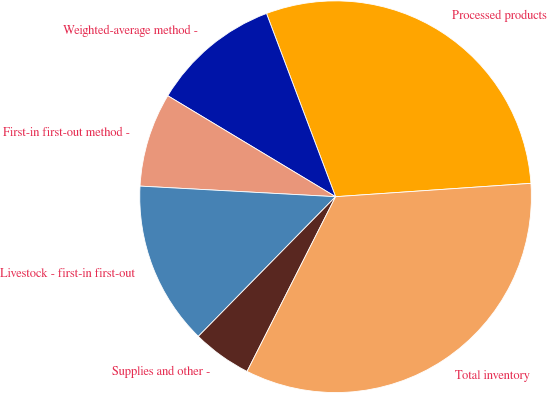Convert chart to OTSL. <chart><loc_0><loc_0><loc_500><loc_500><pie_chart><fcel>Processed products<fcel>Weighted-average method -<fcel>First-in first-out method -<fcel>Livestock - first-in first-out<fcel>Supplies and other -<fcel>Total inventory<nl><fcel>29.65%<fcel>10.64%<fcel>7.76%<fcel>13.5%<fcel>4.9%<fcel>33.55%<nl></chart> 